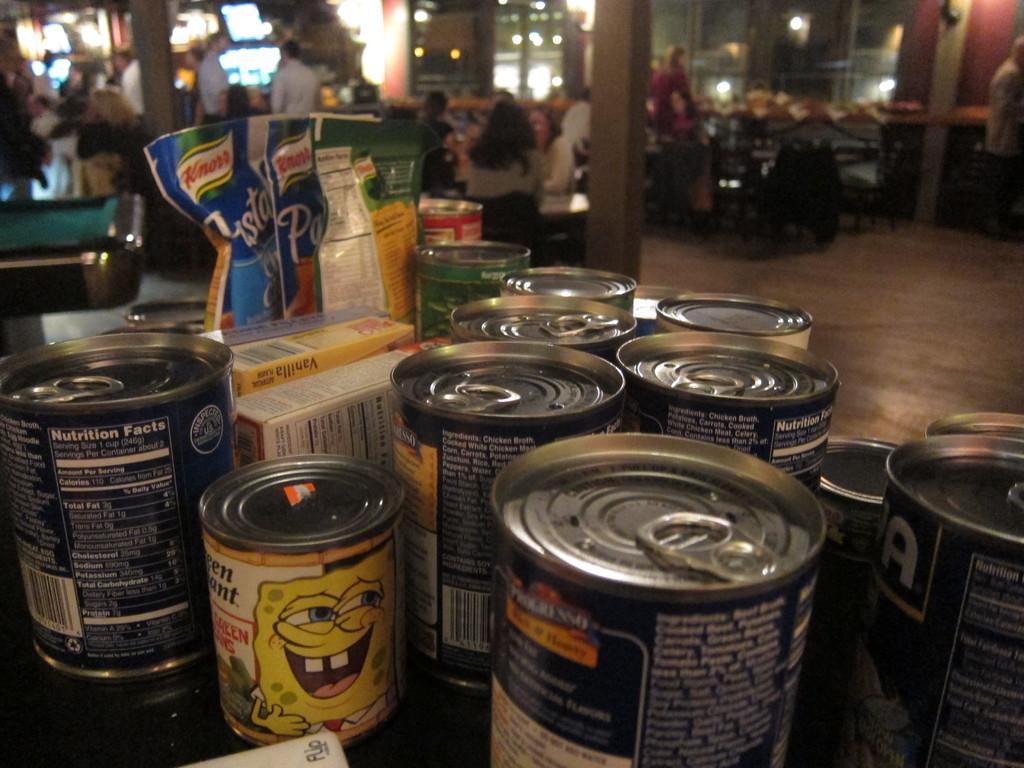Could you give a brief overview of what you see in this image? In this image I can see few tens and few objects. In the background I can see pillars, lights, few people are sitting on the chairs and I can see the blurred background. 